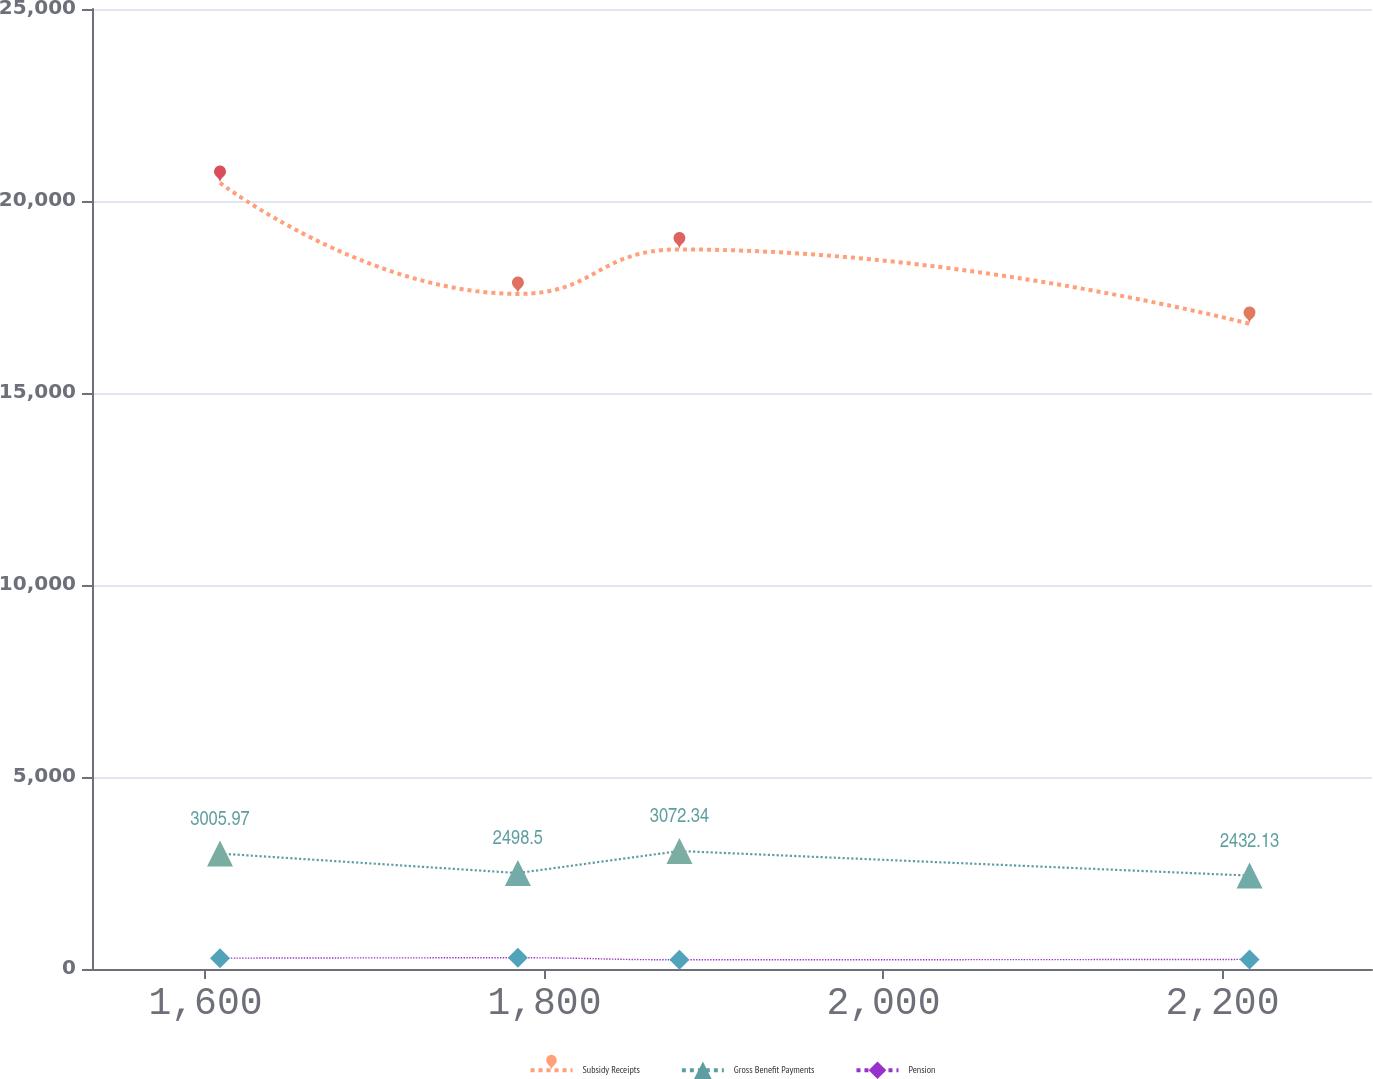Convert chart to OTSL. <chart><loc_0><loc_0><loc_500><loc_500><line_chart><ecel><fcel>Subsidy Receipts<fcel>Gross Benefit Payments<fcel>Pension<nl><fcel>1608.57<fcel>20471.1<fcel>3005.97<fcel>282.39<nl><fcel>1784.32<fcel>17580.5<fcel>2498.5<fcel>292.04<nl><fcel>1879.62<fcel>18738.3<fcel>3072.34<fcel>240.12<nl><fcel>2215.97<fcel>16801.3<fcel>2432.13<fcel>249.78<nl><fcel>2363.74<fcel>15859<fcel>2365.76<fcel>336.67<nl></chart> 